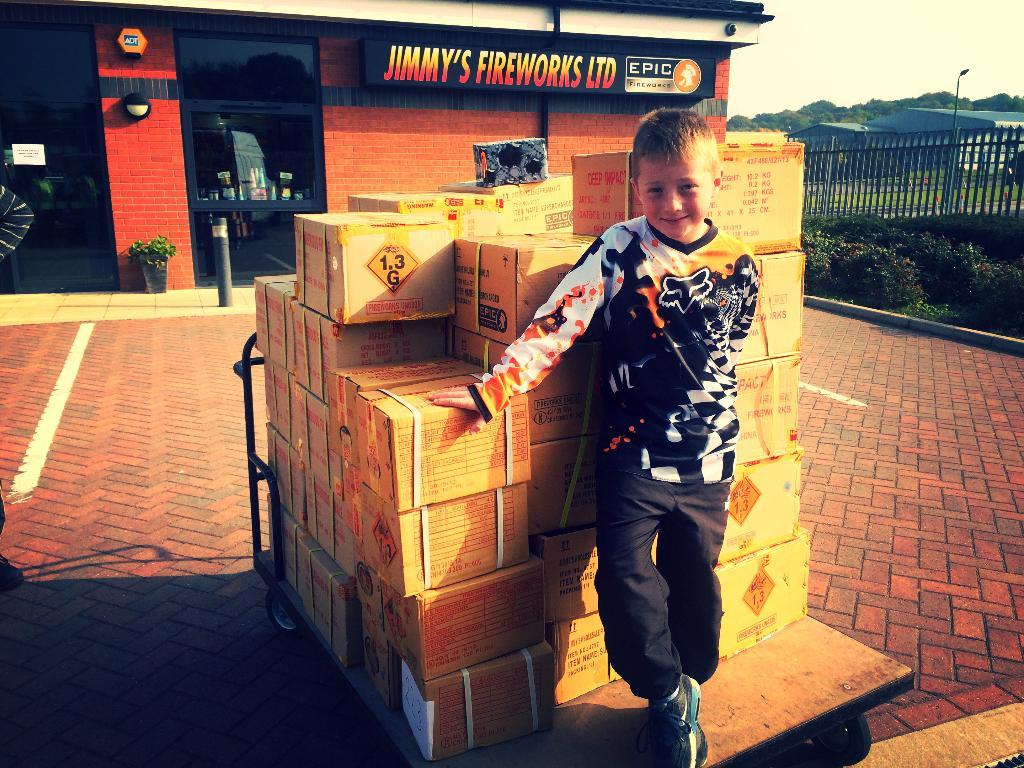<image>
Present a compact description of the photo's key features. A small boy posed in front of Jimmys Firewords LTD. 